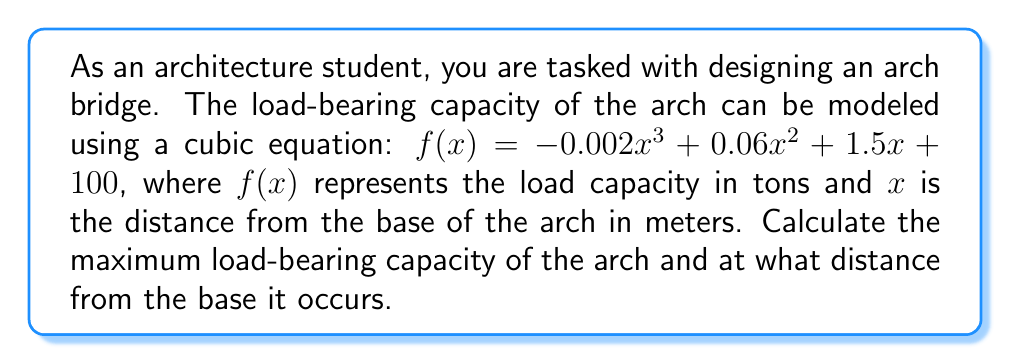Solve this math problem. To find the maximum load-bearing capacity and its location, we need to follow these steps:

1) The maximum of a function occurs where its first derivative is zero. Let's find the first derivative of $f(x)$:

   $f'(x) = -0.006x^2 + 0.12x + 1.5$

2) Set $f'(x) = 0$ and solve for $x$:

   $-0.006x^2 + 0.12x + 1.5 = 0$

3) This is a quadratic equation. We can solve it using the quadratic formula:
   
   $x = \frac{-b \pm \sqrt{b^2 - 4ac}}{2a}$

   Where $a = -0.006$, $b = 0.12$, and $c = 1.5$

4) Substituting these values:

   $x = \frac{-0.12 \pm \sqrt{0.12^2 - 4(-0.006)(1.5)}}{2(-0.006)}$

5) Simplifying:

   $x = \frac{-0.12 \pm \sqrt{0.0144 + 0.036}}{-0.012} = \frac{-0.12 \pm \sqrt{0.0504}}{-0.012} = \frac{-0.12 \pm 0.2245}{-0.012}$

6) This gives us two solutions:

   $x_1 = \frac{-0.12 + 0.2245}{-0.012} = -8.71$ meters
   $x_2 = \frac{-0.12 - 0.2245}{-0.012} = 28.71$ meters

7) Since we're dealing with a physical arch, negative distance doesn't make sense. Therefore, the maximum occurs at $x = 28.71$ meters from the base.

8) To find the maximum load capacity, we substitute this $x$ value back into our original function:

   $f(28.71) = -0.002(28.71)^3 + 0.06(28.71)^2 + 1.5(28.71) + 100$

9) Calculating this:

   $f(28.71) \approx 161.54$ tons

Therefore, the maximum load-bearing capacity is approximately 161.54 tons and occurs 28.71 meters from the base of the arch.
Answer: The maximum load-bearing capacity is approximately 161.54 tons and occurs 28.71 meters from the base of the arch. 